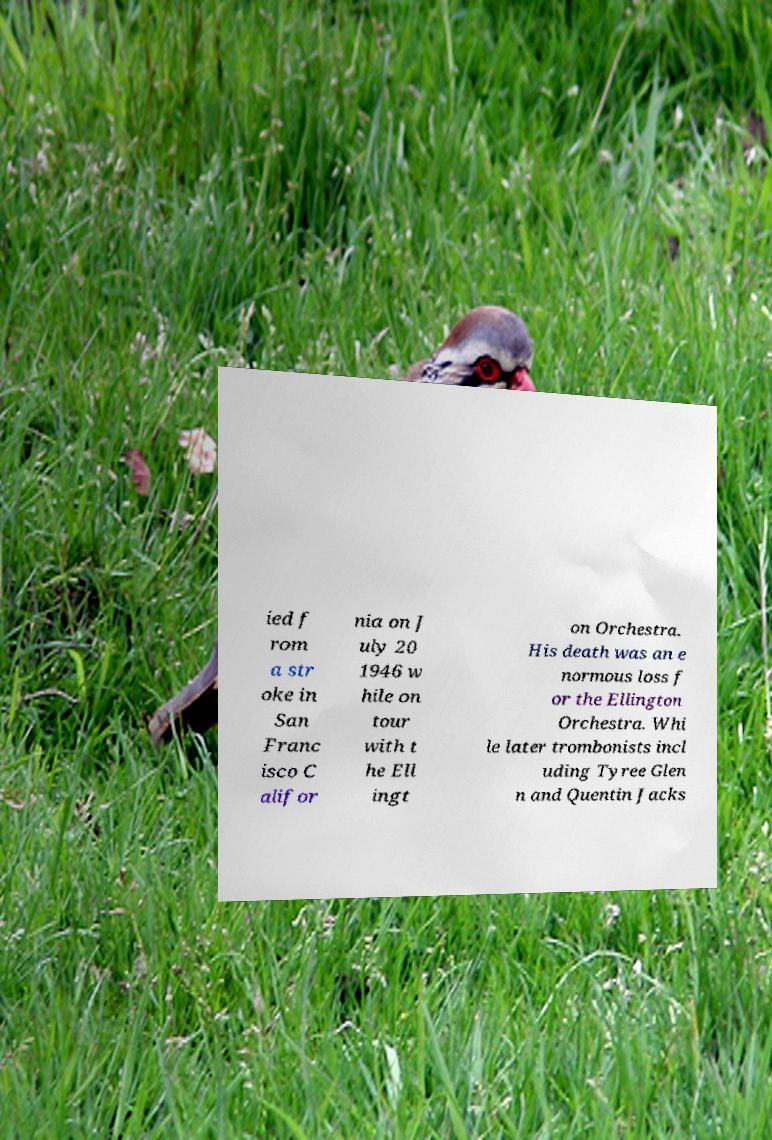Please identify and transcribe the text found in this image. ied f rom a str oke in San Franc isco C alifor nia on J uly 20 1946 w hile on tour with t he Ell ingt on Orchestra. His death was an e normous loss f or the Ellington Orchestra. Whi le later trombonists incl uding Tyree Glen n and Quentin Jacks 